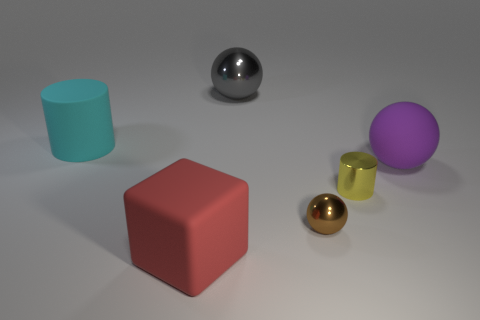Subtract all green blocks. Subtract all green cylinders. How many blocks are left? 1 Subtract all purple cylinders. How many yellow balls are left? 0 Add 3 tiny reds. How many browns exist? 0 Subtract all purple balls. Subtract all tiny spheres. How many objects are left? 4 Add 3 purple objects. How many purple objects are left? 4 Add 6 big metallic things. How many big metallic things exist? 7 Add 1 cubes. How many objects exist? 7 Subtract all brown balls. How many balls are left? 2 Subtract all tiny brown metallic balls. How many balls are left? 2 Subtract 1 red cubes. How many objects are left? 5 